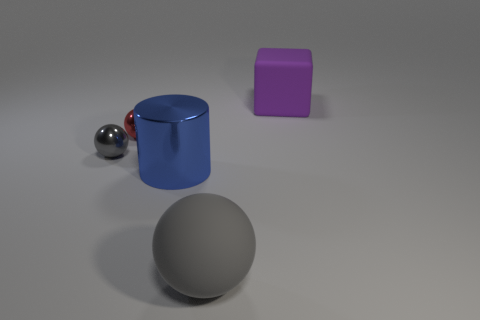Subtract all big matte balls. How many balls are left? 2 Subtract all red spheres. How many spheres are left? 2 Add 1 blue cylinders. How many objects exist? 6 Subtract 1 cylinders. How many cylinders are left? 0 Subtract all red cylinders. How many yellow balls are left? 0 Subtract all big blue balls. Subtract all cylinders. How many objects are left? 4 Add 3 blue cylinders. How many blue cylinders are left? 4 Add 2 large rubber objects. How many large rubber objects exist? 4 Subtract 0 gray blocks. How many objects are left? 5 Subtract all balls. How many objects are left? 2 